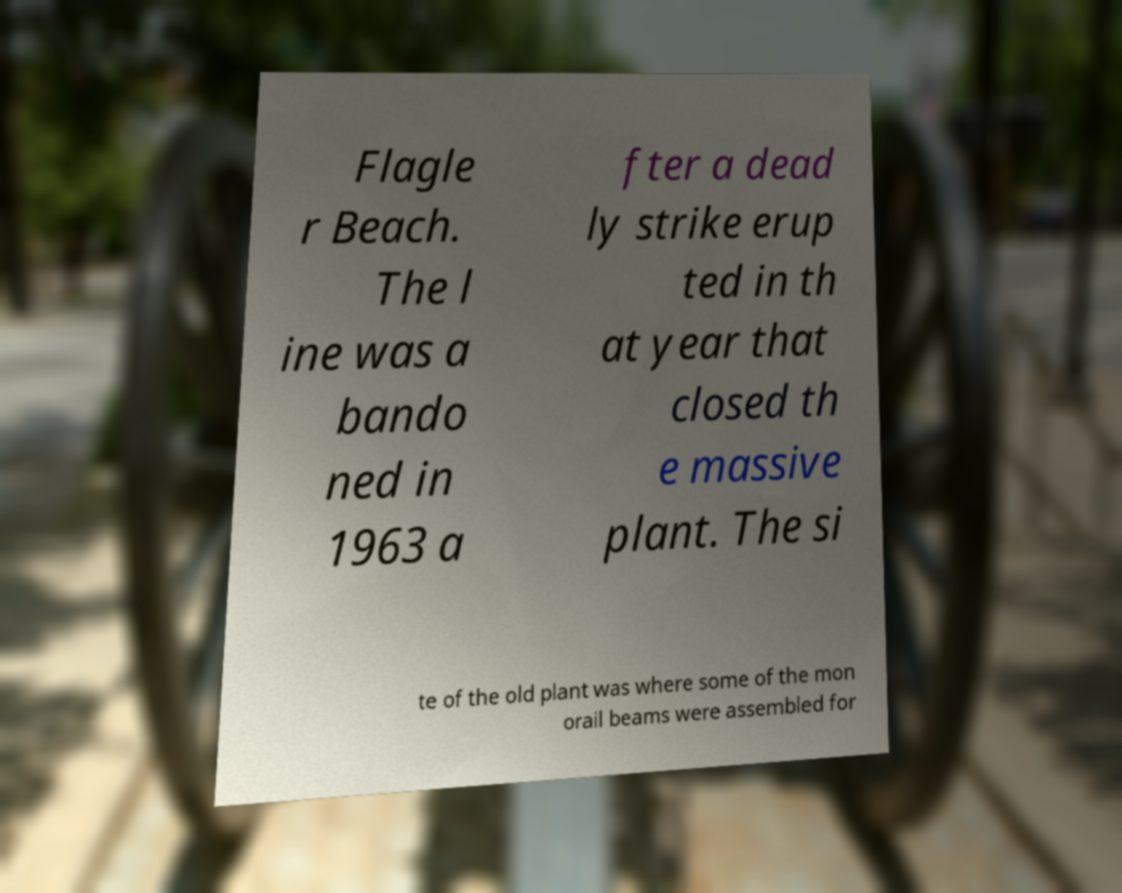Can you accurately transcribe the text from the provided image for me? Flagle r Beach. The l ine was a bando ned in 1963 a fter a dead ly strike erup ted in th at year that closed th e massive plant. The si te of the old plant was where some of the mon orail beams were assembled for 